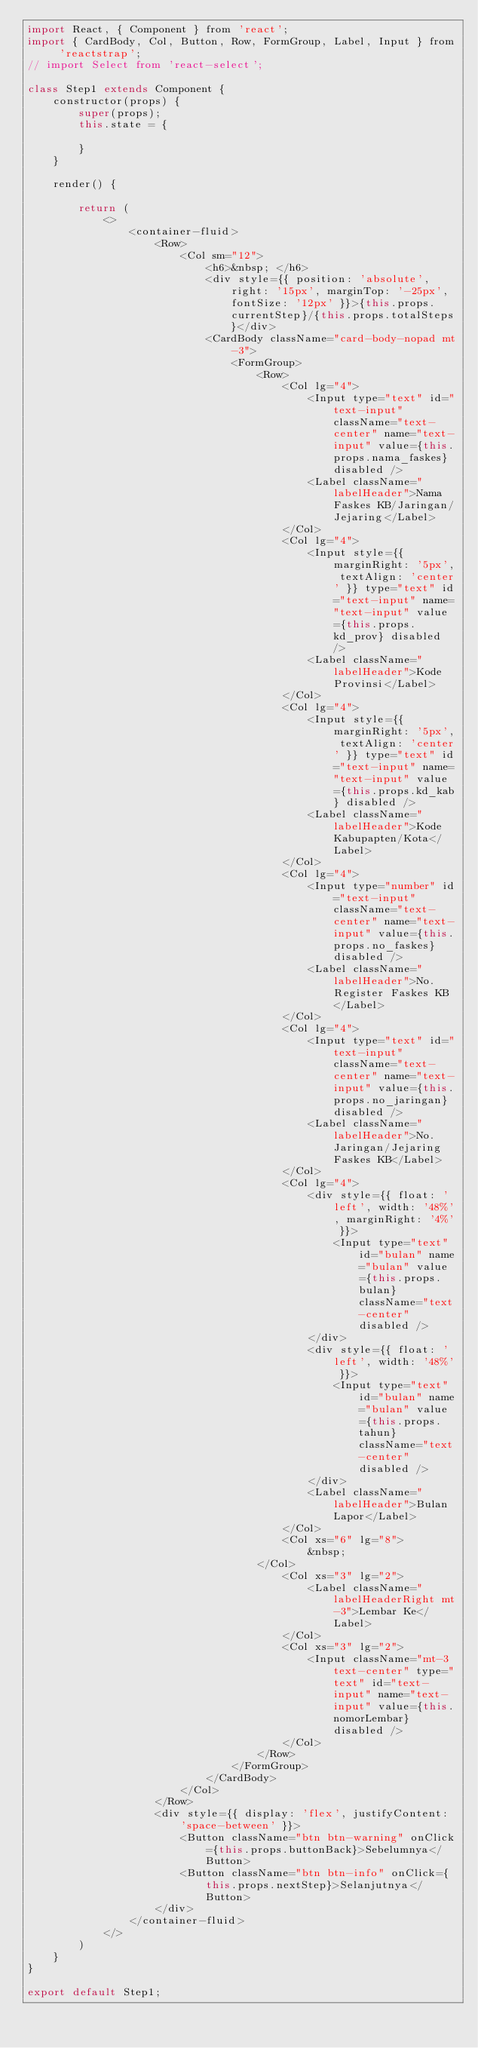<code> <loc_0><loc_0><loc_500><loc_500><_JavaScript_>import React, { Component } from 'react';
import { CardBody, Col, Button, Row, FormGroup, Label, Input } from 'reactstrap';
// import Select from 'react-select';

class Step1 extends Component {
    constructor(props) {
        super(props);
        this.state = {

        }
    }

    render() {

        return (
            <>
                <container-fluid>
                    <Row>
                        <Col sm="12">
                            <h6>&nbsp; </h6>
                            <div style={{ position: 'absolute', right: '15px', marginTop: '-25px', fontSize: '12px' }}>{this.props.currentStep}/{this.props.totalSteps}</div>
                            <CardBody className="card-body-nopad mt-3">
                                <FormGroup>
                                    <Row>
                                        <Col lg="4">
                                            <Input type="text" id="text-input" className="text-center" name="text-input" value={this.props.nama_faskes} disabled />
                                            <Label className="labelHeader">Nama Faskes KB/Jaringan/Jejaring</Label>
                                        </Col>
                                        <Col lg="4">
                                            <Input style={{ marginRight: '5px', textAlign: 'center' }} type="text" id="text-input" name="text-input" value={this.props.kd_prov} disabled />
                                            <Label className="labelHeader">Kode Provinsi</Label>
                                        </Col>
                                        <Col lg="4">
                                            <Input style={{ marginRight: '5px', textAlign: 'center' }} type="text" id="text-input" name="text-input" value={this.props.kd_kab} disabled />
                                            <Label className="labelHeader">Kode Kabupapten/Kota</Label>
                                        </Col>
                                        <Col lg="4">
                                            <Input type="number" id="text-input" className="text-center" name="text-input" value={this.props.no_faskes} disabled />
                                            <Label className="labelHeader">No. Register Faskes KB</Label>
                                        </Col>
                                        <Col lg="4">
                                            <Input type="text" id="text-input" className="text-center" name="text-input" value={this.props.no_jaringan} disabled />
                                            <Label className="labelHeader">No. Jaringan/Jejaring Faskes KB</Label>
                                        </Col>
                                        <Col lg="4">
                                            <div style={{ float: 'left', width: '48%', marginRight: '4%' }}>
                                                <Input type="text" id="bulan" name="bulan" value={this.props.bulan} className="text-center" disabled />
                                            </div>
                                            <div style={{ float: 'left', width: '48%' }}>
                                                <Input type="text" id="bulan" name="bulan" value={this.props.tahun} className="text-center" disabled />
                                            </div>
                                            <Label className="labelHeader">Bulan Lapor</Label>
                                        </Col>
                                        <Col xs="6" lg="8">
                                            &nbsp;
                                    </Col>
                                        <Col xs="3" lg="2">
                                            <Label className="labelHeaderRight mt-3">Lembar Ke</Label>
                                        </Col>
                                        <Col xs="3" lg="2">
                                            <Input className="mt-3 text-center" type="text" id="text-input" name="text-input" value={this.nomorLembar} disabled />
                                        </Col>
                                    </Row>
                                </FormGroup>
                            </CardBody>
                        </Col>
                    </Row>
                    <div style={{ display: 'flex', justifyContent: 'space-between' }}>
                        <Button className="btn btn-warning" onClick={this.props.buttonBack}>Sebelumnya</Button>
                        <Button className="btn btn-info" onClick={this.props.nextStep}>Selanjutnya</Button>
                    </div>
                </container-fluid>
            </>
        )
    }
}

export default Step1;</code> 